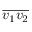<formula> <loc_0><loc_0><loc_500><loc_500>{ \overline { { v _ { 1 } v _ { 2 } } } }</formula> 